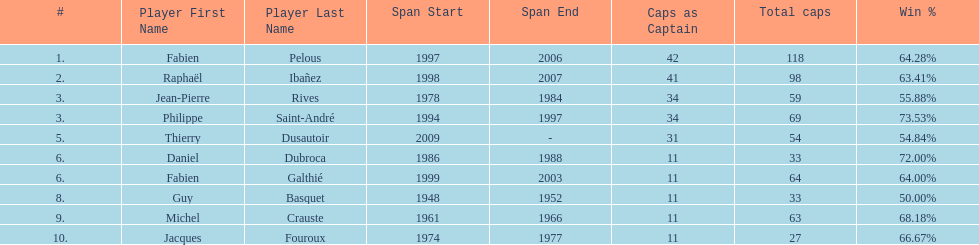How long did fabien pelous serve as captain in the french national rugby team? 9 years. 